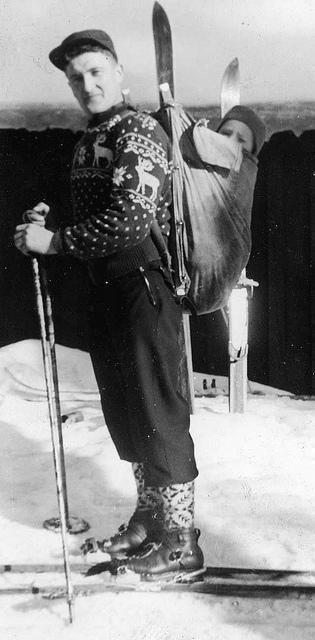What relation is the man to the boy in his backpack?
Choose the right answer and clarify with the format: 'Answer: answer
Rationale: rationale.'
Options: Pastor, neighbor, teacher, father. Answer: father.
Rationale: The man is the boy's dad. 